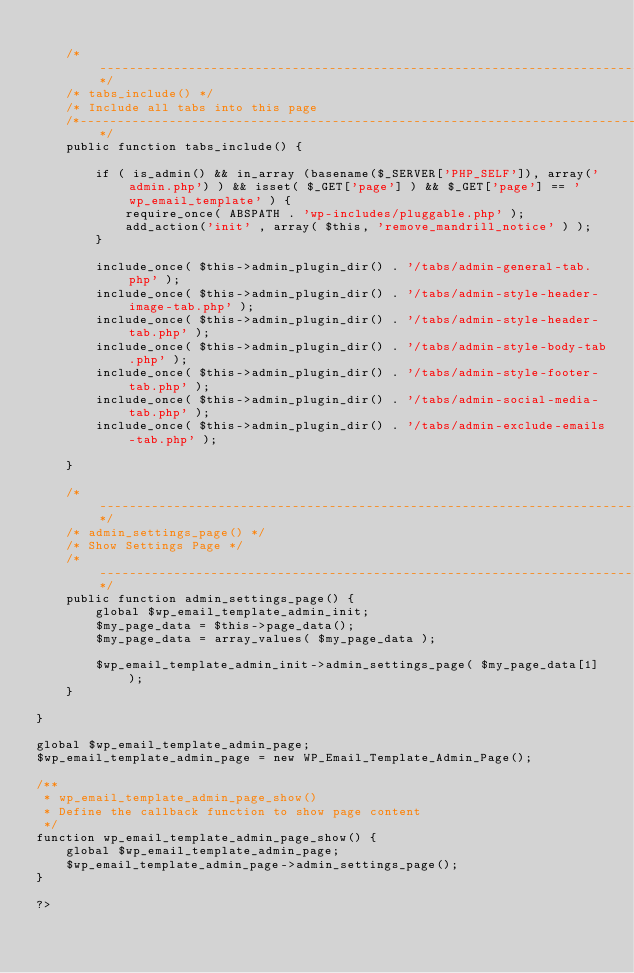Convert code to text. <code><loc_0><loc_0><loc_500><loc_500><_PHP_>	
	/*-----------------------------------------------------------------------------------*/
	/* tabs_include() */
	/* Include all tabs into this page
	/*-----------------------------------------------------------------------------------*/
	public function tabs_include() {
		
		if ( is_admin() && in_array (basename($_SERVER['PHP_SELF']), array('admin.php') ) && isset( $_GET['page'] ) && $_GET['page'] == 'wp_email_template' ) {
			require_once( ABSPATH . 'wp-includes/pluggable.php' );
			add_action('init' , array( $this, 'remove_mandrill_notice' ) );
		}
		
		include_once( $this->admin_plugin_dir() . '/tabs/admin-general-tab.php' );
		include_once( $this->admin_plugin_dir() . '/tabs/admin-style-header-image-tab.php' );
		include_once( $this->admin_plugin_dir() . '/tabs/admin-style-header-tab.php' );
		include_once( $this->admin_plugin_dir() . '/tabs/admin-style-body-tab.php' );
		include_once( $this->admin_plugin_dir() . '/tabs/admin-style-footer-tab.php' );
		include_once( $this->admin_plugin_dir() . '/tabs/admin-social-media-tab.php' );
		include_once( $this->admin_plugin_dir() . '/tabs/admin-exclude-emails-tab.php' );
		
	}
	
	/*-----------------------------------------------------------------------------------*/
	/* admin_settings_page() */
	/* Show Settings Page */
	/*-----------------------------------------------------------------------------------*/
	public function admin_settings_page() {
		global $wp_email_template_admin_init;
		$my_page_data = $this->page_data();
		$my_page_data = array_values( $my_page_data );
		
		$wp_email_template_admin_init->admin_settings_page( $my_page_data[1] );
	}
	
}

global $wp_email_template_admin_page;
$wp_email_template_admin_page = new WP_Email_Template_Admin_Page();

/** 
 * wp_email_template_admin_page_show()
 * Define the callback function to show page content
 */
function wp_email_template_admin_page_show() {
	global $wp_email_template_admin_page;
	$wp_email_template_admin_page->admin_settings_page();
}

?></code> 